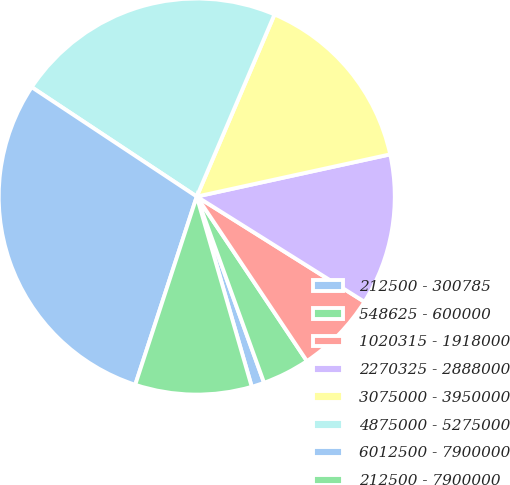Convert chart. <chart><loc_0><loc_0><loc_500><loc_500><pie_chart><fcel>212500 - 300785<fcel>548625 - 600000<fcel>1020315 - 1918000<fcel>2270325 - 2888000<fcel>3075000 - 3950000<fcel>4875000 - 5275000<fcel>6012500 - 7900000<fcel>212500 - 7900000<nl><fcel>1.04%<fcel>3.87%<fcel>6.69%<fcel>12.34%<fcel>15.16%<fcel>22.11%<fcel>29.29%<fcel>9.51%<nl></chart> 